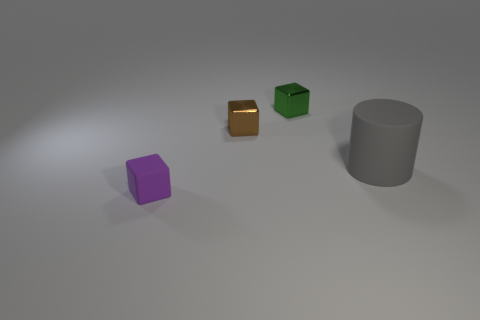Are there any tiny green things?
Ensure brevity in your answer.  Yes. What is the color of the matte object that is to the right of the small rubber block?
Your response must be concise. Gray. There is a big matte cylinder; are there any brown metal things to the left of it?
Provide a succinct answer. Yes. Is the number of brown metal cubes greater than the number of big blue metal objects?
Offer a very short reply. Yes. The matte object to the right of the tiny thing in front of the metal cube that is in front of the green block is what color?
Your answer should be very brief. Gray. What is the color of the other thing that is the same material as the purple thing?
Offer a terse response. Gray. Is there anything else that has the same size as the gray matte cylinder?
Offer a very short reply. No. How many things are either blocks behind the tiny purple thing or cubes that are in front of the large gray thing?
Ensure brevity in your answer.  3. There is a metal block left of the green shiny object; is its size the same as the rubber object that is behind the purple matte cube?
Provide a short and direct response. No. What is the color of the matte thing that is the same shape as the brown shiny thing?
Keep it short and to the point. Purple. 